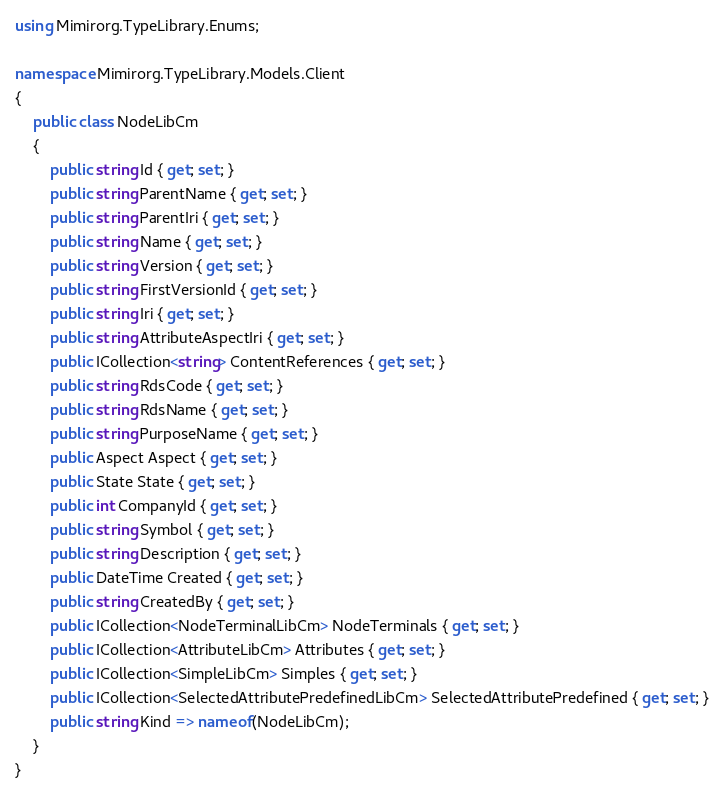Convert code to text. <code><loc_0><loc_0><loc_500><loc_500><_C#_>using Mimirorg.TypeLibrary.Enums;

namespace Mimirorg.TypeLibrary.Models.Client
{
    public class NodeLibCm
    {
        public string Id { get; set; }
        public string ParentName { get; set; }
        public string ParentIri { get; set; }
        public string Name { get; set; }
        public string Version { get; set; }
        public string FirstVersionId { get; set; }
        public string Iri { get; set; }
        public string AttributeAspectIri { get; set; }
        public ICollection<string> ContentReferences { get; set; }
        public string RdsCode { get; set; }
        public string RdsName { get; set; }
        public string PurposeName { get; set; }
        public Aspect Aspect { get; set; }
        public State State { get; set; }
        public int CompanyId { get; set; }
        public string Symbol { get; set; }
        public string Description { get; set; }
        public DateTime Created { get; set; }
        public string CreatedBy { get; set; }
        public ICollection<NodeTerminalLibCm> NodeTerminals { get; set; }
        public ICollection<AttributeLibCm> Attributes { get; set; }
        public ICollection<SimpleLibCm> Simples { get; set; }
        public ICollection<SelectedAttributePredefinedLibCm> SelectedAttributePredefined { get; set; }
        public string Kind => nameof(NodeLibCm);
    }
}</code> 